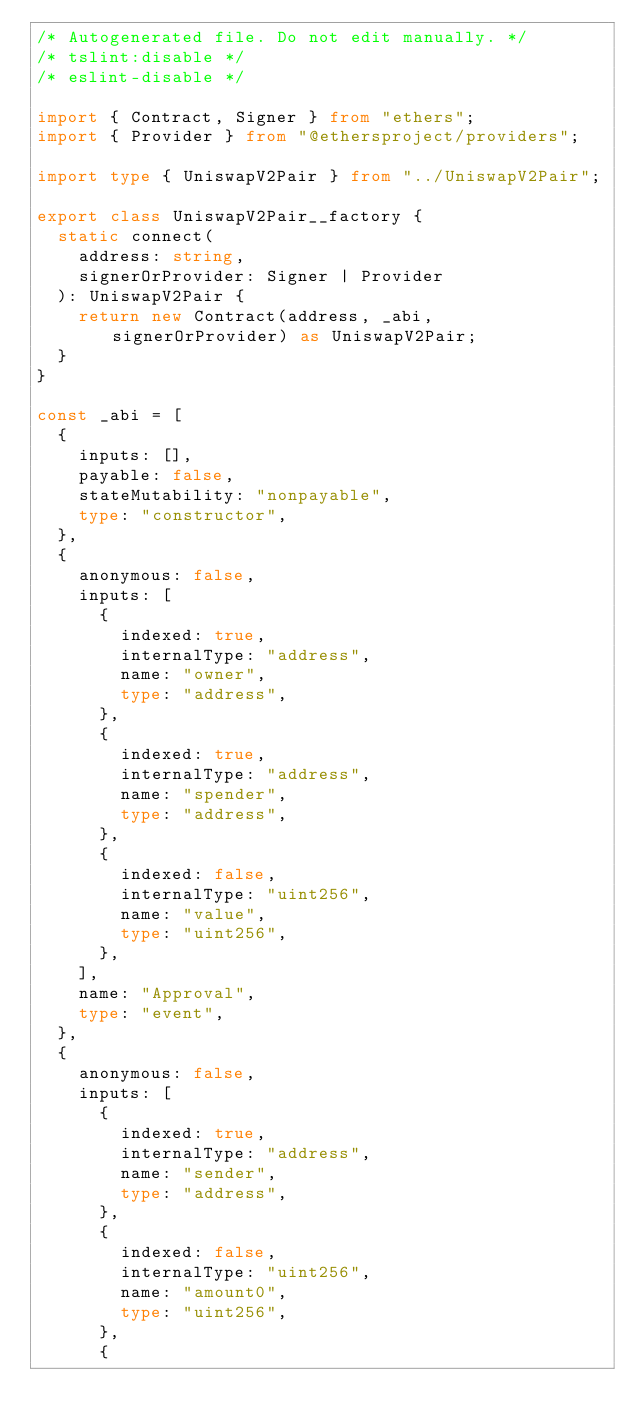Convert code to text. <code><loc_0><loc_0><loc_500><loc_500><_TypeScript_>/* Autogenerated file. Do not edit manually. */
/* tslint:disable */
/* eslint-disable */

import { Contract, Signer } from "ethers";
import { Provider } from "@ethersproject/providers";

import type { UniswapV2Pair } from "../UniswapV2Pair";

export class UniswapV2Pair__factory {
  static connect(
    address: string,
    signerOrProvider: Signer | Provider
  ): UniswapV2Pair {
    return new Contract(address, _abi, signerOrProvider) as UniswapV2Pair;
  }
}

const _abi = [
  {
    inputs: [],
    payable: false,
    stateMutability: "nonpayable",
    type: "constructor",
  },
  {
    anonymous: false,
    inputs: [
      {
        indexed: true,
        internalType: "address",
        name: "owner",
        type: "address",
      },
      {
        indexed: true,
        internalType: "address",
        name: "spender",
        type: "address",
      },
      {
        indexed: false,
        internalType: "uint256",
        name: "value",
        type: "uint256",
      },
    ],
    name: "Approval",
    type: "event",
  },
  {
    anonymous: false,
    inputs: [
      {
        indexed: true,
        internalType: "address",
        name: "sender",
        type: "address",
      },
      {
        indexed: false,
        internalType: "uint256",
        name: "amount0",
        type: "uint256",
      },
      {</code> 